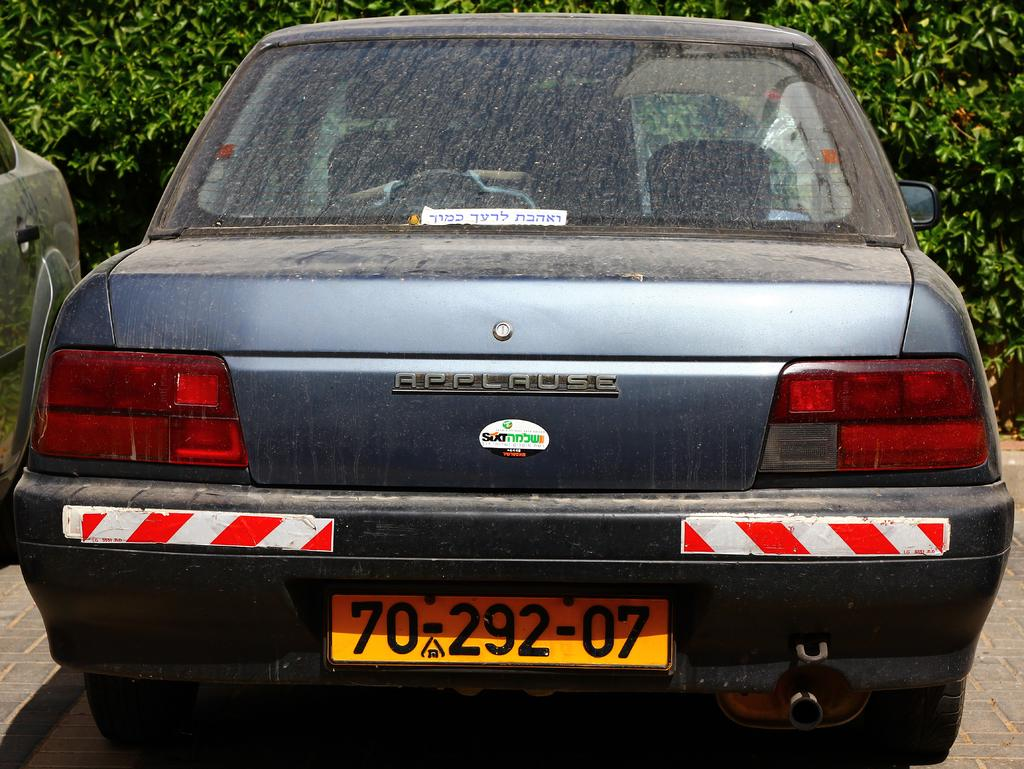<image>
Create a compact narrative representing the image presented. The back side of a dirty Applause automobile. 